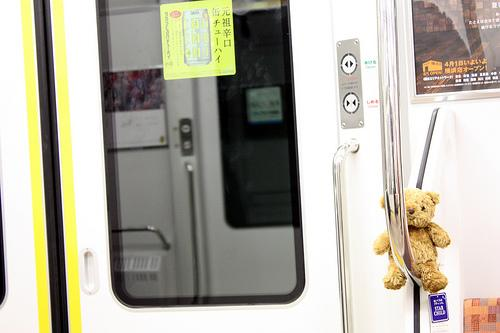Identify the main object hanging on the door handle. A brown stuffed teddy bear is hanging on the door handle. Provide a brief overview of the entire scene captured in the image. The image captures a train door with a stuffed teddy bear hanging on the handle, buttons beside it for opening and closing the door, and various labels and advertisements on the walls and door. How is the teddy bear positioned in relation to the door handle? The teddy bear is hanging from the door handle, facing forward. Can you count how many buttons are related to opening and closing the door? There are two buttons related to opening and closing the door. How many unique objects are there in the image? Considering different labels separately, there are 26 unique objects in the image. What kind of tag is attached to the teddy bear's leg? A blue tag is attached to the teddy bear's leg. Do the labels and advertisements in the image appear to contain any important message? The labels and advertisements might contain important information, but their content is not provided in the bounding boxes. Tell me what the bear on the handle is holding on to. The bear on the handle is holding onto a silver handle on the wall. 